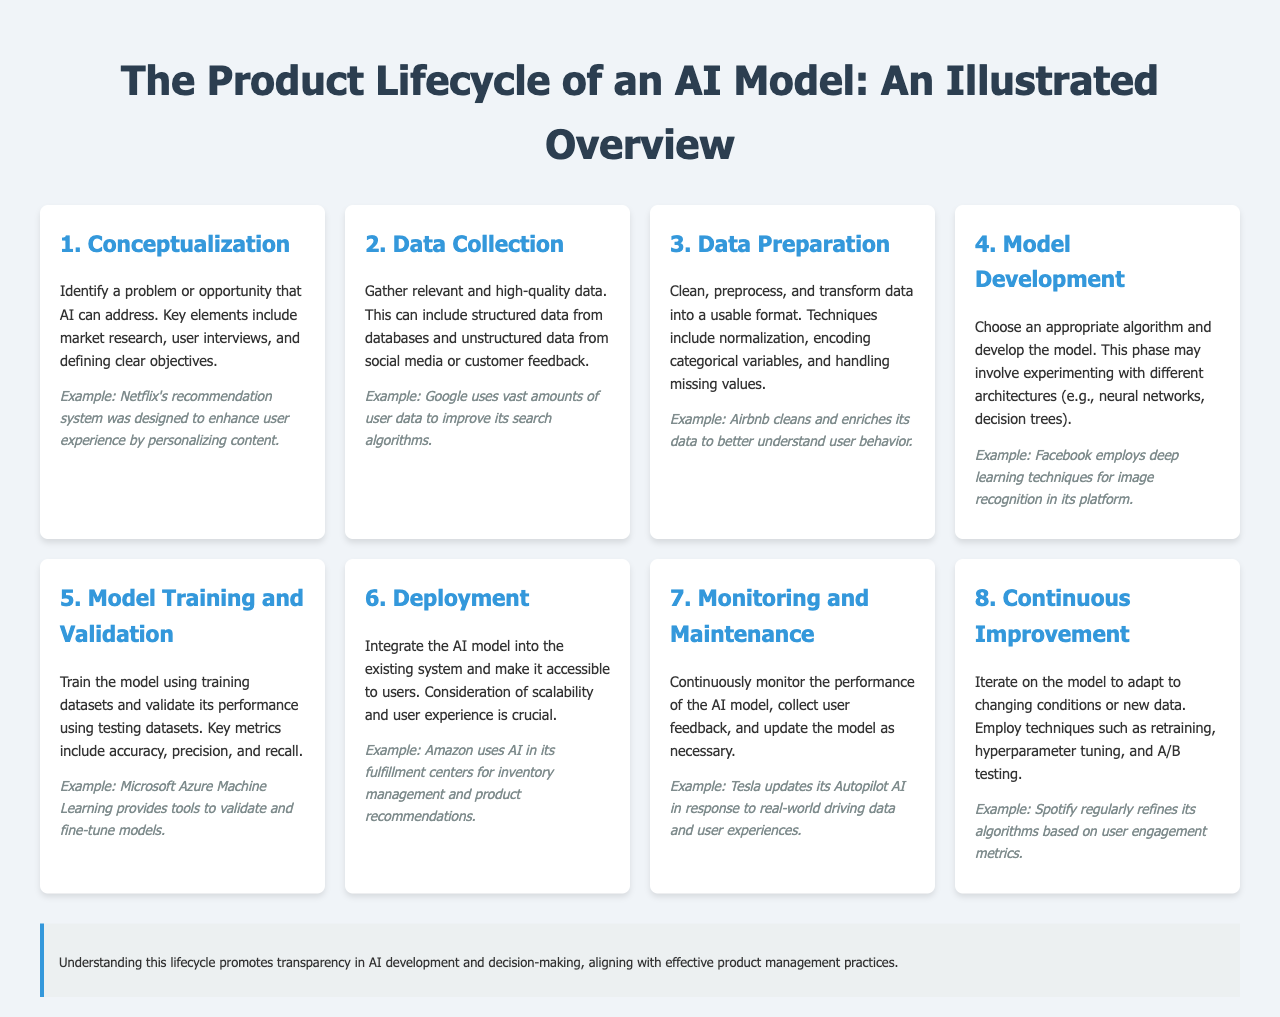what is the first step in the AI model lifecycle? The first step in the AI model lifecycle is to identify a problem or opportunity that AI can address.
Answer: Conceptualization what is one example given for the data collection step? The document provides an example of a company that uses vast amounts of user data to improve its search algorithms.
Answer: Google what are the key metrics used in model training and validation? The document lists important performance measures for AI models during their training and validation phase.
Answer: accuracy, precision, and recall how many steps are there in the AI model lifecycle? The lifecycle of an AI model consists of several distinct stages detailed in the document.
Answer: 8 what practice is emphasized for continuous improvement? The document suggests a method to adapt AI models to evolving conditions or datasets through a specific practice.
Answer: retraining which company is mentioned in relation to monitoring and maintenance? The document provides an example of a company that updates its AI based on real-world data and user experiences.
Answer: Tesla what should be monitored after deployment? Key aspects that need to be monitored continuously include performance and user feedback following the AI model integration.
Answer: performance what is the purpose of the lifecycle overview? The document states that understanding this lifecycle promotes a specific aspect of AI development practices.
Answer: transparency 